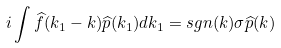Convert formula to latex. <formula><loc_0><loc_0><loc_500><loc_500>i \int \widehat { f } ( k _ { 1 } - k ) \widehat { p } ( k _ { 1 } ) d k _ { 1 } = s g n ( k ) \sigma \widehat { p } ( k )</formula> 